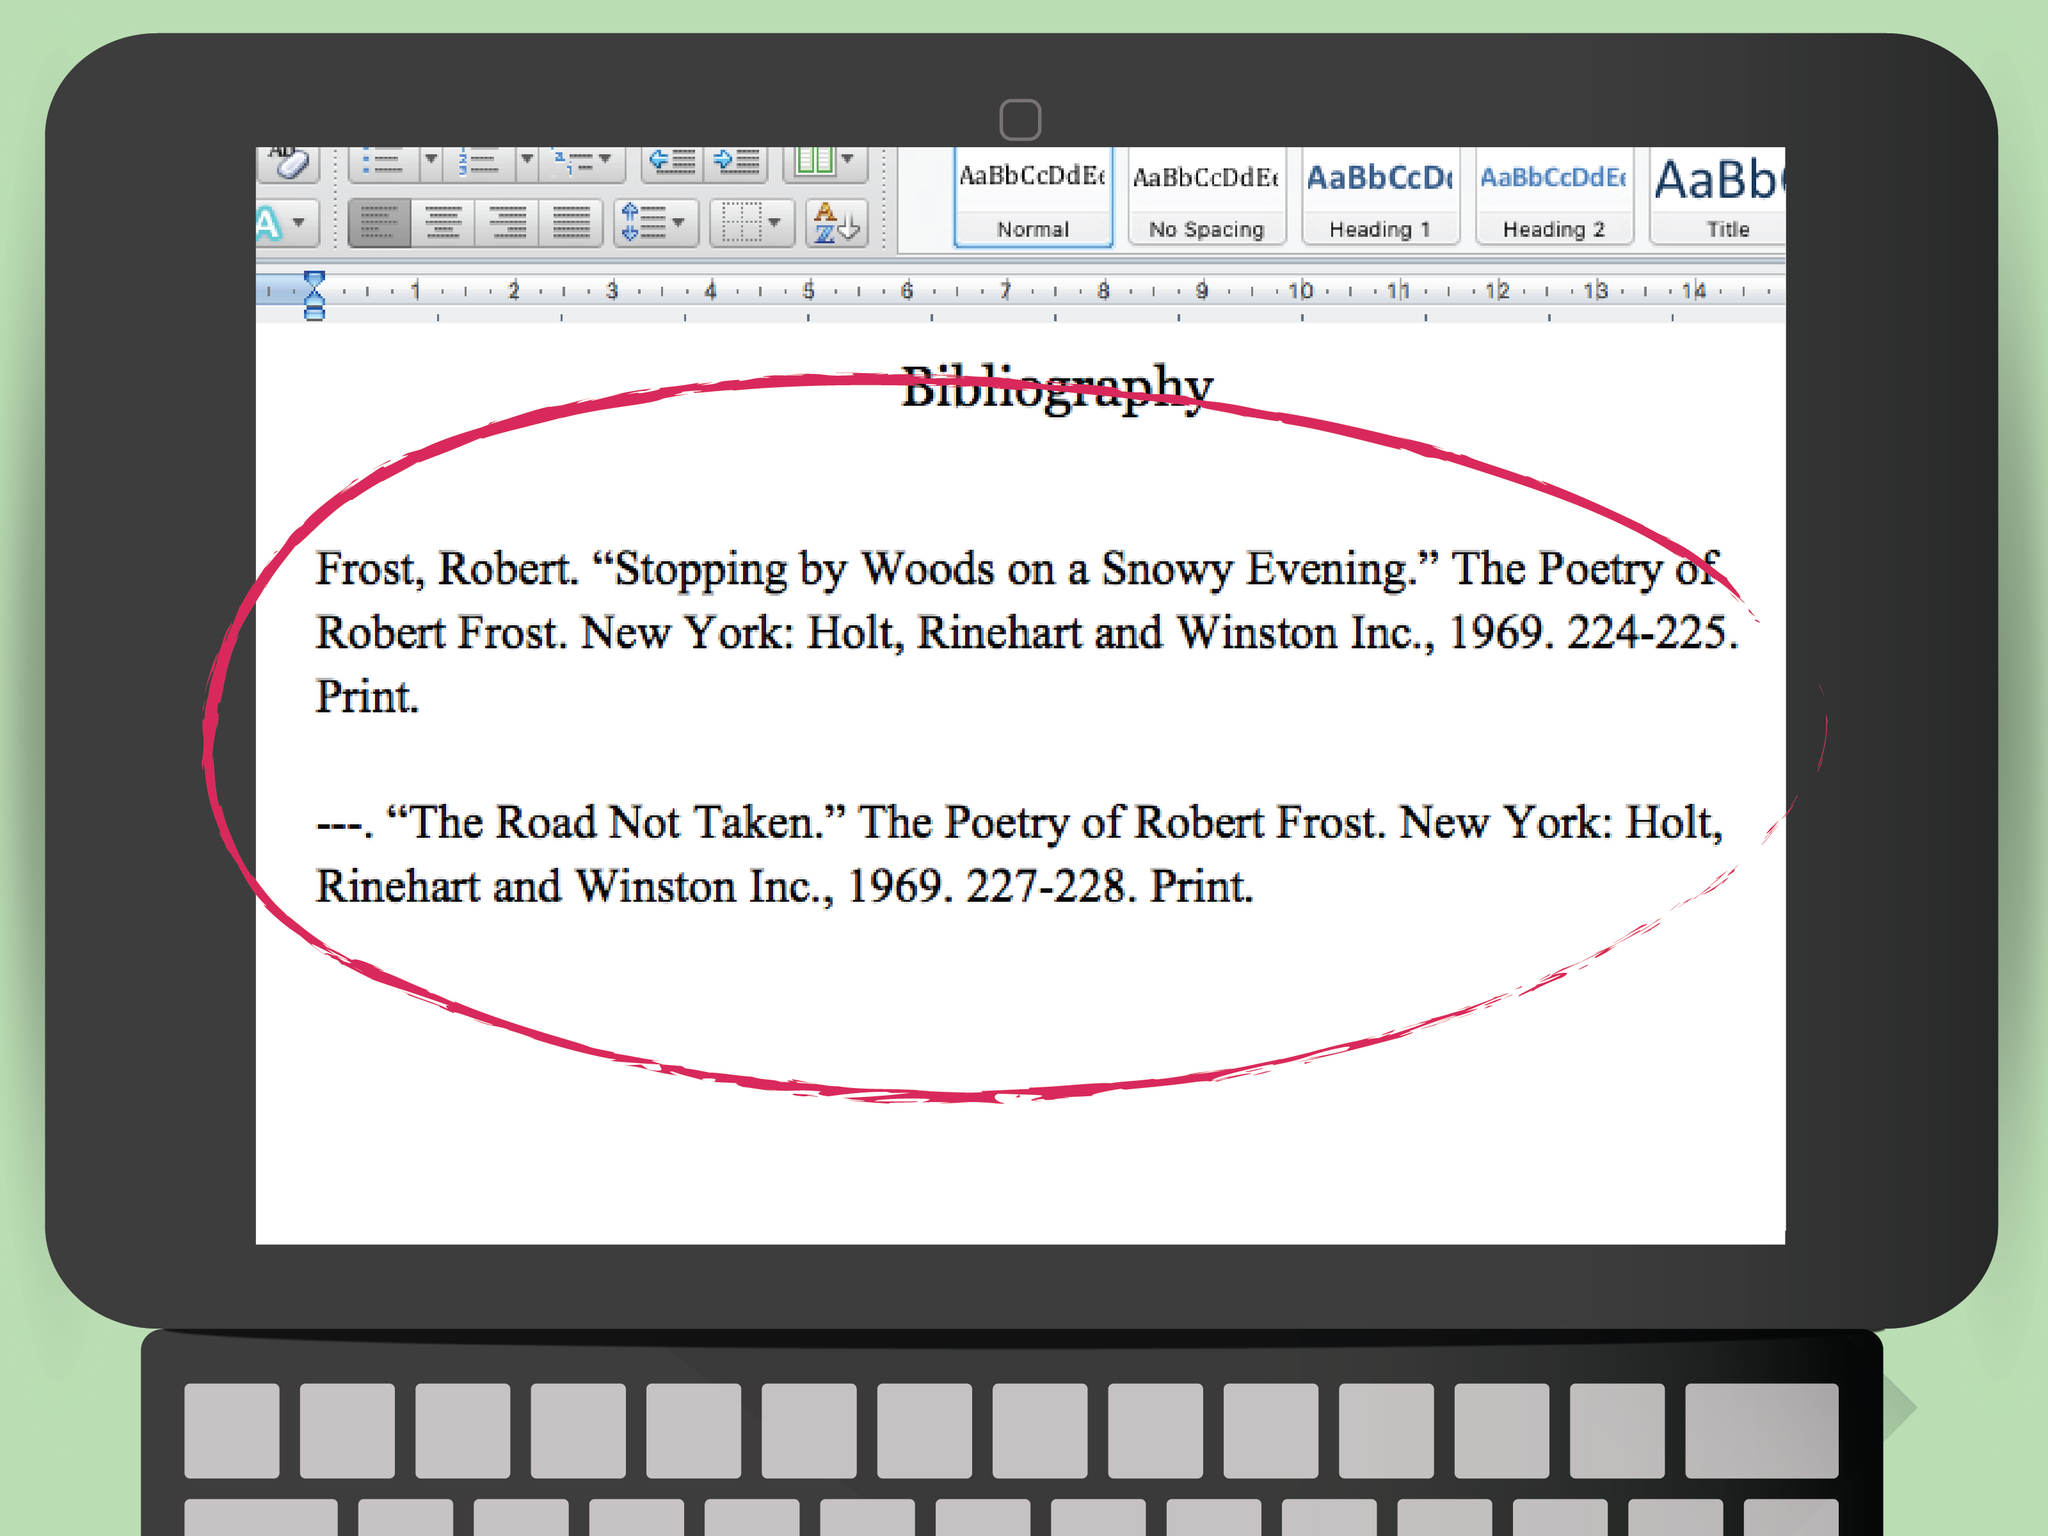What unique perspectives can you provide on the significance of the bibliography entries' publication years? The publication year of 1969 for these works of Robert Frost tells us they were part of a collection or reprint during a period of significant cultural change. The late 1960s was a time of social upheaval and transformation in the United States, which means these reprints could have been part of a broader movement to revisit classic literature during times of questioning and reevaluation of societal norms. It’s interesting to consider how contemporary readers of that era might have interpreted Frost's themes of decision and introspection within the context of their own experiences. Draw a parallel between a 1960s event and the themes in one of these poems. The theme of making choices in 'The Road Not Taken' can be paralleled with the civil rights movement in the 1960s. The choices individuals and society faced about equality and justice were pivotal. Just like in Frost's poem, where the traveler stands at a fork in the road, the 1960s were a time when the United States confronted the crucial decision of embracing civil rights and equality. This parallel highlights how individual decisions collectively shape the trajectory of history. Imagine writing a dialogue between Robert Frost and a 1960s civil rights activist. What topics might they discuss? In a dialogue between Robert Frost and a 1960s civil rights activist, they might discuss the struggle for equality and the profound impacts of choices. Frost could bring up the metaphorical roads from his poetry, discussing the weight of decisions that define one's life path. The activist might share firsthand experiences of pivotal moments in the movement, relating these to Frost's contemplation of paths not taken. They might find common ground in the themes of bravery, the unknown future, and the hope for change depicted in Frost's works and the reality of the activism period. 